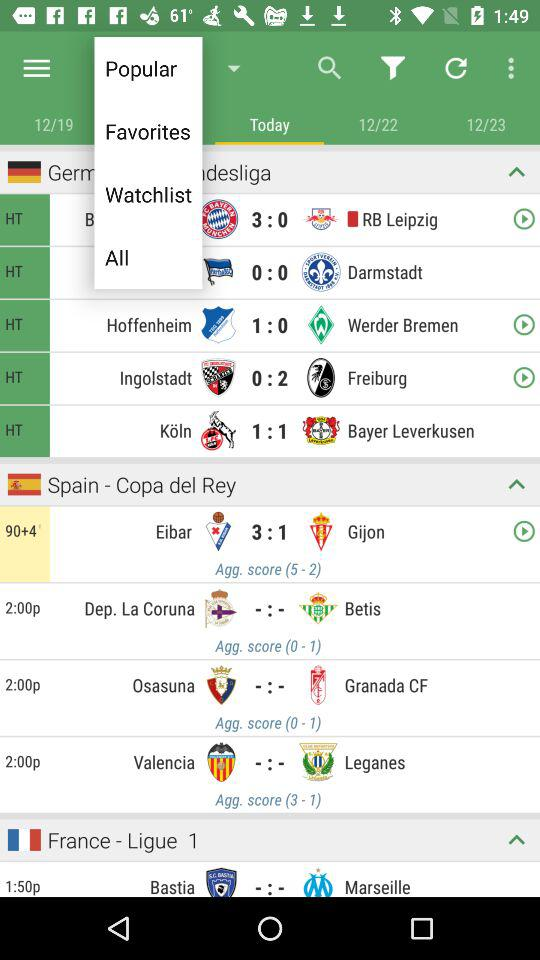What is the number of goals scored by "Eibar"? The number of goals scored by "Eibar" is 3. 